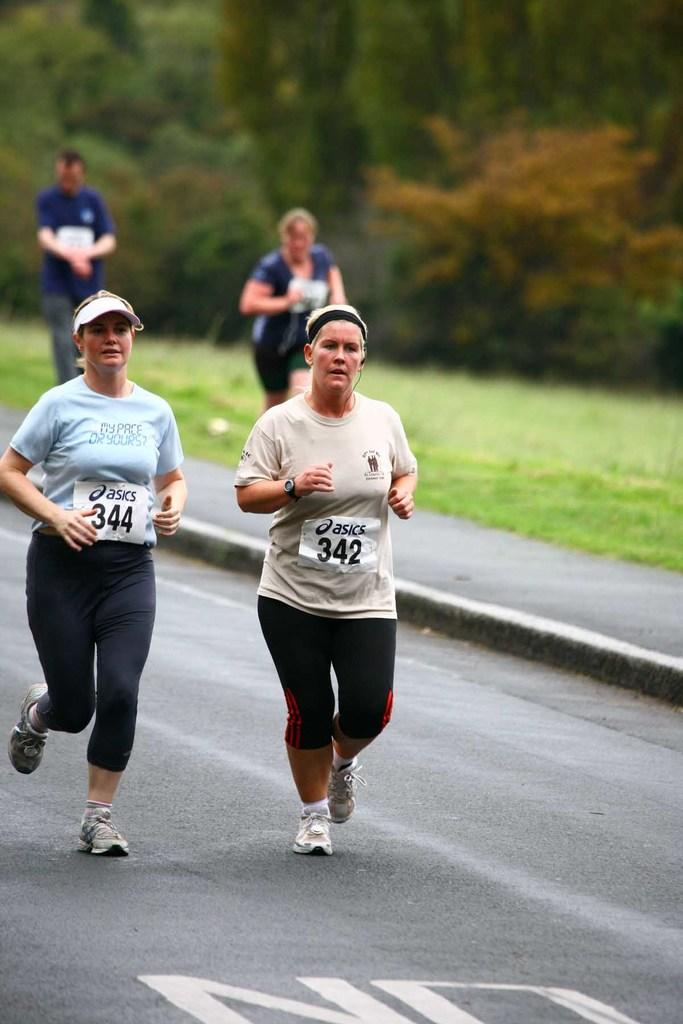What is happening in the image involving a group of people? Some people are running on the road, and a woman is running on a pathway. Can you describe the environment where the people are running? There is grass and trees visible in the background of the image. What type of surface are the people running on? The people are running on a road and a pathway. What type of calculator is being used by the woman running on the pathway? There is no calculator present in the image; the woman is running on a pathway. What religious symbols can be seen in the image? There are no religious symbols visible in the image. 